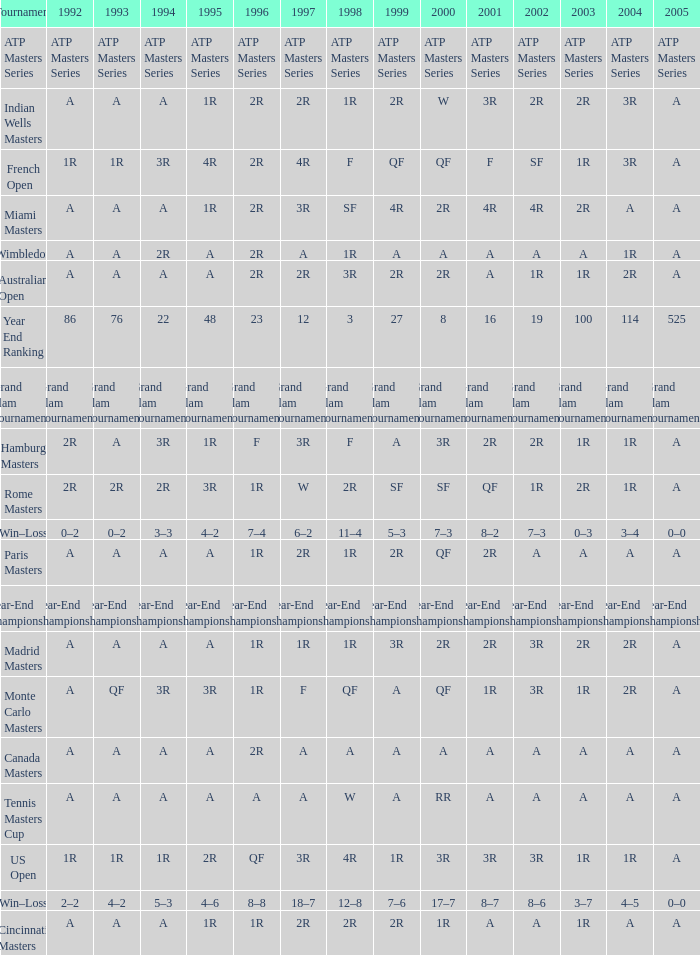What is Tournament, when 2000 is "A"? Wimbledon, Canada Masters. 